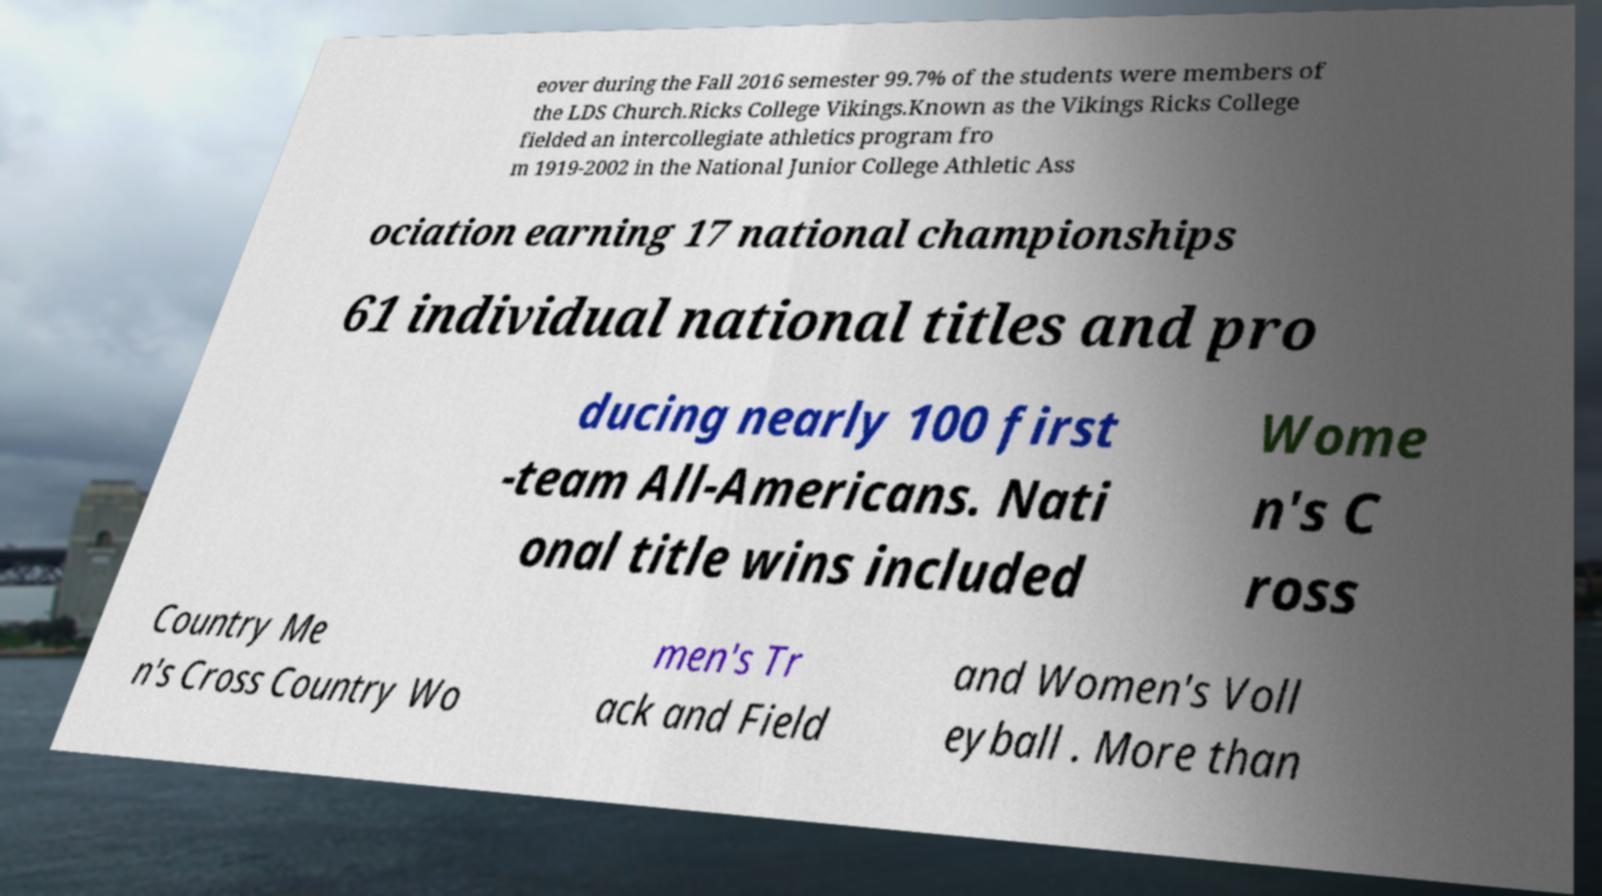Could you extract and type out the text from this image? eover during the Fall 2016 semester 99.7% of the students were members of the LDS Church.Ricks College Vikings.Known as the Vikings Ricks College fielded an intercollegiate athletics program fro m 1919-2002 in the National Junior College Athletic Ass ociation earning 17 national championships 61 individual national titles and pro ducing nearly 100 first -team All-Americans. Nati onal title wins included Wome n's C ross Country Me n's Cross Country Wo men's Tr ack and Field and Women's Voll eyball . More than 